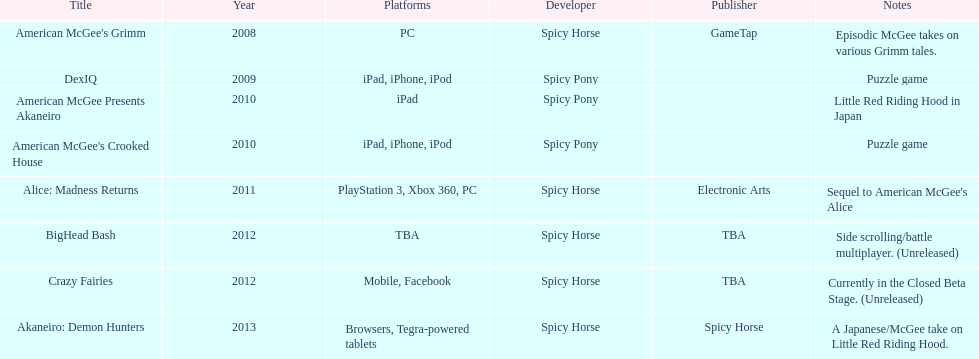What are the titles of all published games? American McGee's Grimm, DexIQ, American McGee Presents Akaneiro, American McGee's Crooked House, Alice: Madness Returns, BigHead Bash, Crazy Fairies, Akaneiro: Demon Hunters. What are the names of all the game publishers? GameTap, , , , Electronic Arts, TBA, TBA, Spicy Horse. Which game title is associated with electronic arts? Alice: Madness Returns. 